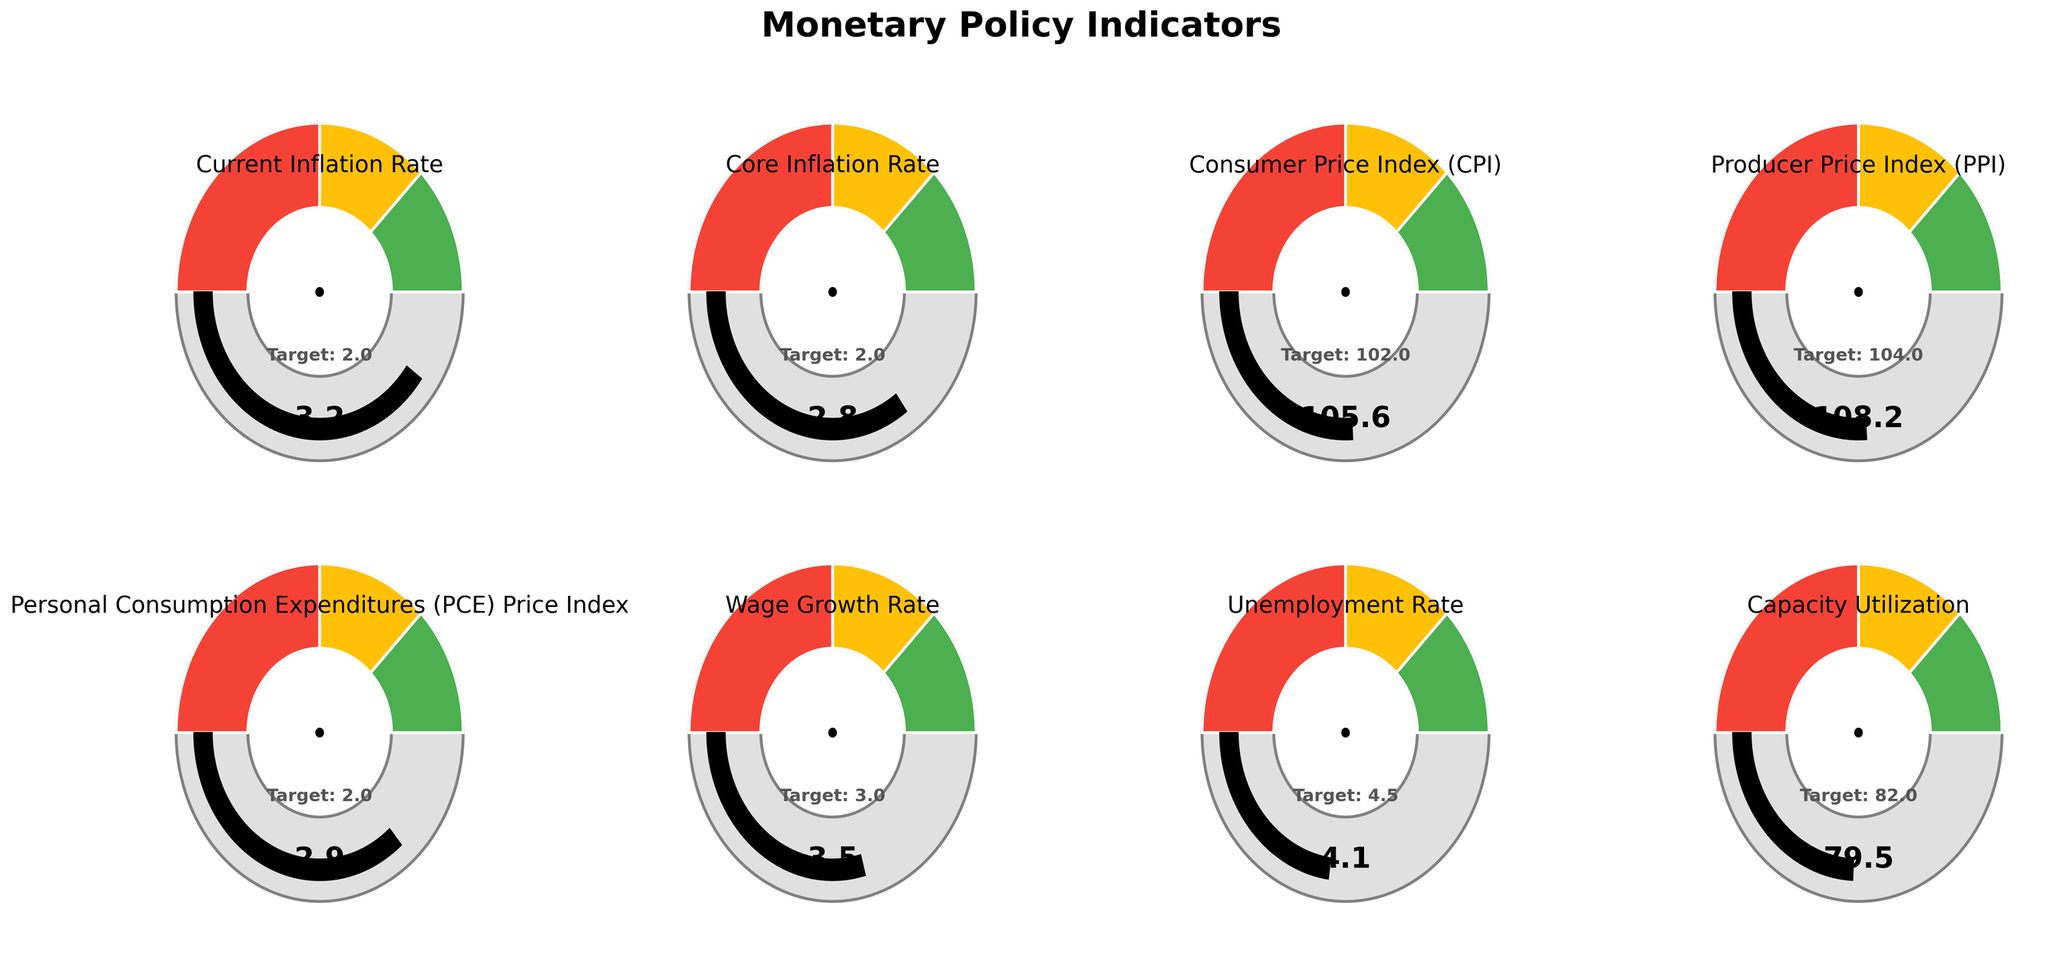What is the target rate for the Current Inflation Rate? The target rate for the Current Inflation Rate is displayed within the gauge chart for this indicator.
Answer: 2.0 Which indicator has the highest value compared to its target? By observing all the gauge charts, the 'Producer Price Index (PPI)' shows the greatest deviation from its target compared to its actual value.
Answer: Producer Price Index (PPI) What is the difference between the Consumer Price Index (CPI) value and its target? From the gauge chart, the Consumer Price Index (CPI) has a value of 105.6 with a target of 102. The difference can be calculated as 105.6 - 102 = 3.6.
Answer: 3.6 Is the Unemployment Rate above or below its target? Observing the gauge chart for the Unemployment Rate, the actual value is 4.1, which is below the target of 4.5.
Answer: Below Which indicators have their actual values close to their target values? By inspecting the distance between the values and target points on the gauge charts, the 'Wage Growth Rate' (3.5 actual vs. 3.0 target) and 'Core Inflation Rate' (2.8 actual vs. 2.0 target) indicators are relatively close to their targets.
Answer: Wage Growth Rate, Core Inflation Rate How many indicators are above their target values? From the eight gauge charts, the indicators that are above their target values are 'Current Inflation Rate', 'Core Inflation Rate', 'Consumer Price Index (CPI)', 'Producer Price Index (PPI)', 'Personal Consumption Expenditures (PCE) Price Index', and 'Wage Growth Rate'. This counts to six indicators.
Answer: 6 Among 'Capacity Utilization' and 'Core Inflation Rate', which one is performing better relative to its target? 'Capacity Utilization' has a target of 82.0 and an actual value of 79.5, performing below its target. 'Core Inflation Rate' has a target of 2.0 and an actual value of 2.8, performing below its target as well. Comparing the two, 'Core Inflation Rate' is closer to its target compared to 'Capacity Utilization'.
Answer: Core Inflation Rate What is the relation between the Wage Growth Rate and its target compared to the Unemployment Rate and its target? 'Wage Growth Rate' has an actual value of 3.5 with a target of 3.0, slightly exceeding its target. 'Unemployment Rate' has an actual value of 4.1 with a target of 4.5, slightly below its target. In relation, Wage Growth Rate is above its target while Unemployment Rate is below its target.
Answer: Wage Growth Rate above, Unemployment Rate below 